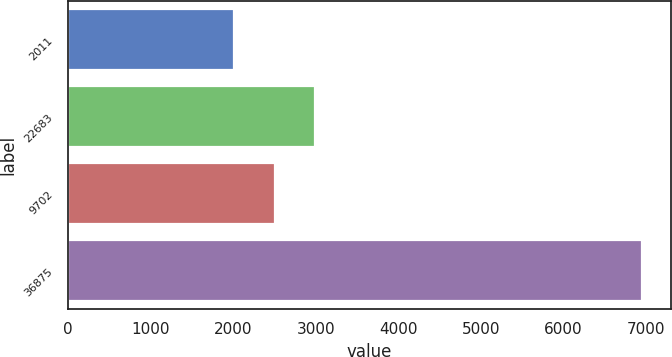Convert chart. <chart><loc_0><loc_0><loc_500><loc_500><bar_chart><fcel>2011<fcel>22683<fcel>9702<fcel>36875<nl><fcel>2010<fcel>2998<fcel>2504<fcel>6950<nl></chart> 